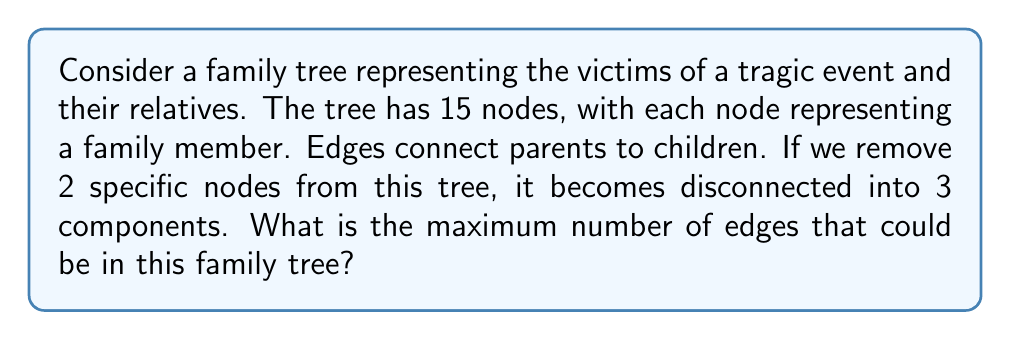Help me with this question. Let's approach this step-by-step:

1) First, recall that a tree with $n$ nodes always has $n-1$ edges.

2) In this case, we start with 15 nodes, so the original tree has 14 edges.

3) When we remove 2 nodes, we're left with 13 nodes.

4) If these 13 nodes form 3 disconnected components, it means we've removed at least 2 edges (to disconnect the tree into 3 parts).

5) However, each removed node could have been connected to multiple edges. Let's consider the maximum possible:

   - If one of the removed nodes was a leaf (connected to only one edge), and the other was connected to 3 edges, we would remove a total of 4 edges.
   - This is the maximum possible because if we removed 5 or more edges, we would end up with more than 3 components.

6) So, after removing 2 nodes and up to 4 edges, we're left with 13 nodes and at least 10 edges (14 - 4 = 10).

7) For these 13 nodes to form a maximum of 3 components, they must form 3 separate trees.

8) Three separate trees with a total of 13 nodes would have $(n_1-1) + (n_2-1) + (n_3-1) = 10$ edges, where $n_1 + n_2 + n_3 = 13$.

Therefore, the maximum number of edges in the original tree is consistent with our initial calculation of 14.
Answer: The maximum number of edges in this family tree is 14. 